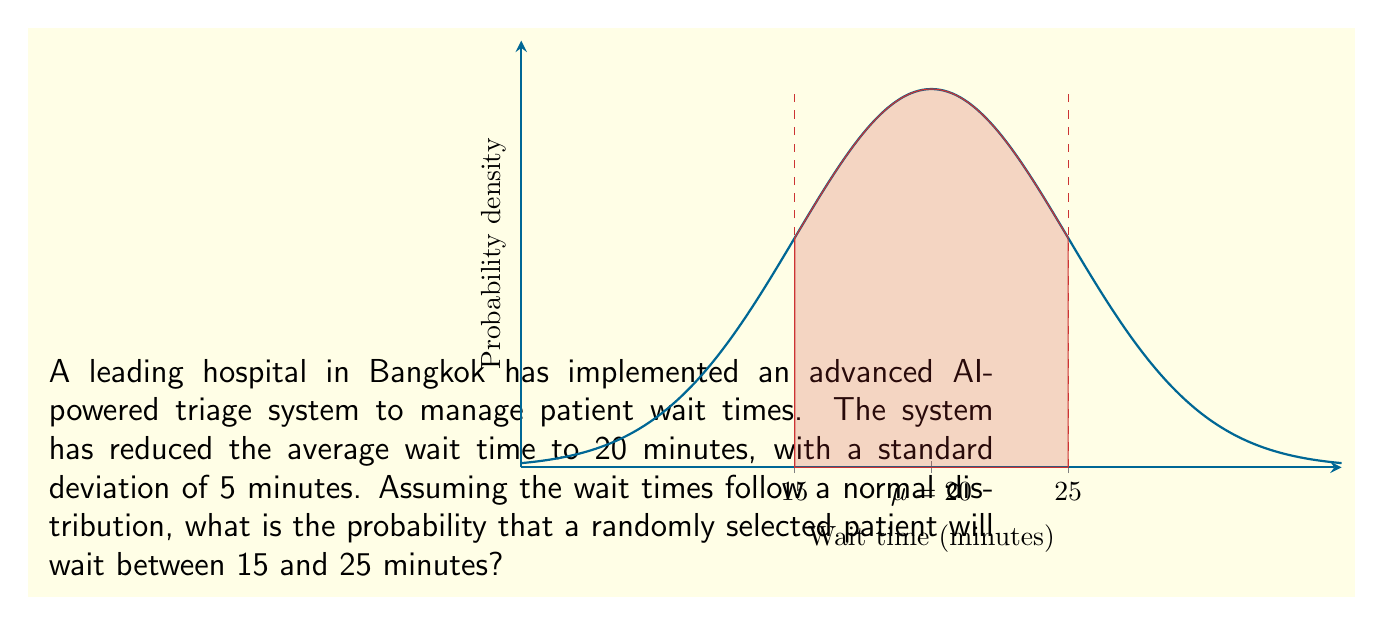Help me with this question. To solve this problem, we'll use the properties of the normal distribution and the concept of z-scores.

Given:
- Mean wait time ($\mu$) = 20 minutes
- Standard deviation ($\sigma$) = 5 minutes
- We want to find P(15 < X < 25), where X is the wait time

Step 1: Calculate the z-scores for the lower and upper bounds.
For 15 minutes: $z_1 = \frac{15 - 20}{5} = -1$
For 25 minutes: $z_2 = \frac{25 - 20}{5} = 1$

Step 2: Use the standard normal distribution table or a calculator to find the area between these z-scores.
P(-1 < Z < 1) = P(Z < 1) - P(Z < -1)
              = 0.8413 - 0.1587
              = 0.6826

Step 3: Convert the probability to a percentage.
0.6826 * 100 = 68.26%

Therefore, the probability that a randomly selected patient will wait between 15 and 25 minutes is approximately 68.26%.
Answer: 68.26% 